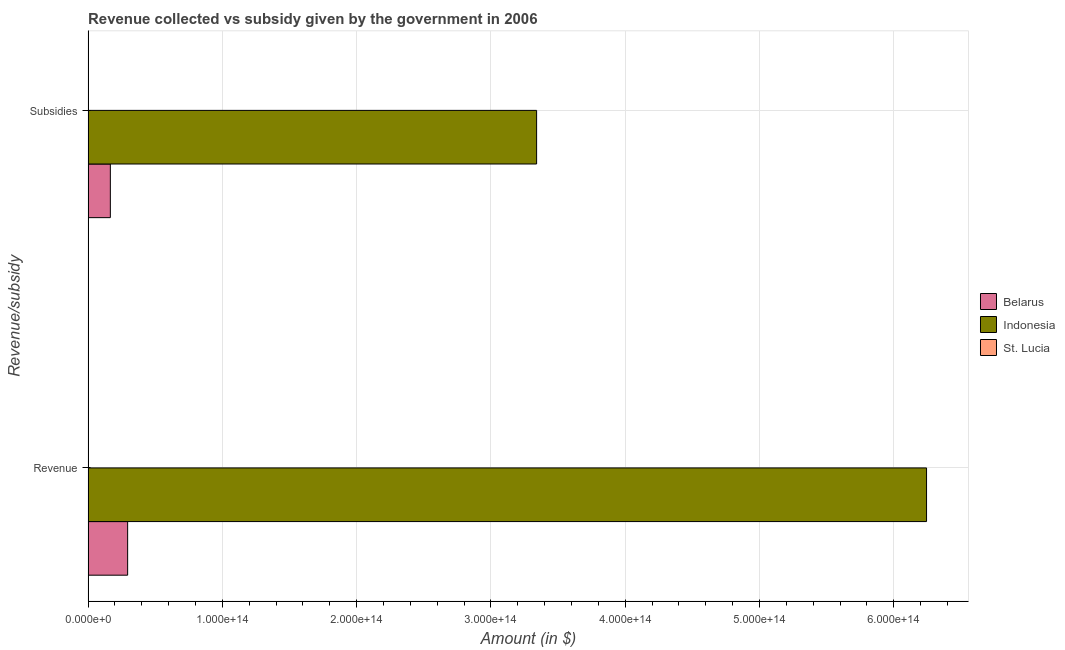How many different coloured bars are there?
Keep it short and to the point. 3. How many bars are there on the 1st tick from the top?
Make the answer very short. 3. What is the label of the 1st group of bars from the top?
Your answer should be very brief. Subsidies. What is the amount of subsidies given in Indonesia?
Provide a succinct answer. 3.34e+14. Across all countries, what is the maximum amount of subsidies given?
Provide a short and direct response. 3.34e+14. Across all countries, what is the minimum amount of subsidies given?
Your answer should be very brief. 4.63e+07. In which country was the amount of subsidies given maximum?
Provide a short and direct response. Indonesia. In which country was the amount of subsidies given minimum?
Offer a terse response. St. Lucia. What is the total amount of revenue collected in the graph?
Ensure brevity in your answer.  6.54e+14. What is the difference between the amount of revenue collected in St. Lucia and that in Belarus?
Provide a short and direct response. -2.94e+13. What is the difference between the amount of revenue collected in Indonesia and the amount of subsidies given in Belarus?
Keep it short and to the point. 6.08e+14. What is the average amount of revenue collected per country?
Keep it short and to the point. 2.18e+14. What is the difference between the amount of subsidies given and amount of revenue collected in Belarus?
Your answer should be compact. -1.29e+13. In how many countries, is the amount of revenue collected greater than 380000000000000 $?
Offer a very short reply. 1. What is the ratio of the amount of revenue collected in Belarus to that in St. Lucia?
Your response must be concise. 4.55e+04. Is the amount of subsidies given in St. Lucia less than that in Indonesia?
Provide a succinct answer. Yes. In how many countries, is the amount of revenue collected greater than the average amount of revenue collected taken over all countries?
Offer a very short reply. 1. What does the 3rd bar from the top in Subsidies represents?
Offer a terse response. Belarus. What does the 2nd bar from the bottom in Subsidies represents?
Make the answer very short. Indonesia. How many bars are there?
Make the answer very short. 6. How many countries are there in the graph?
Your answer should be very brief. 3. What is the difference between two consecutive major ticks on the X-axis?
Your response must be concise. 1.00e+14. Where does the legend appear in the graph?
Your response must be concise. Center right. How many legend labels are there?
Keep it short and to the point. 3. How are the legend labels stacked?
Give a very brief answer. Vertical. What is the title of the graph?
Make the answer very short. Revenue collected vs subsidy given by the government in 2006. What is the label or title of the X-axis?
Keep it short and to the point. Amount (in $). What is the label or title of the Y-axis?
Give a very brief answer. Revenue/subsidy. What is the Amount (in $) in Belarus in Revenue?
Ensure brevity in your answer.  2.94e+13. What is the Amount (in $) in Indonesia in Revenue?
Offer a terse response. 6.24e+14. What is the Amount (in $) in St. Lucia in Revenue?
Your answer should be very brief. 6.48e+08. What is the Amount (in $) in Belarus in Subsidies?
Your response must be concise. 1.66e+13. What is the Amount (in $) of Indonesia in Subsidies?
Keep it short and to the point. 3.34e+14. What is the Amount (in $) in St. Lucia in Subsidies?
Offer a terse response. 4.63e+07. Across all Revenue/subsidy, what is the maximum Amount (in $) of Belarus?
Make the answer very short. 2.94e+13. Across all Revenue/subsidy, what is the maximum Amount (in $) of Indonesia?
Your answer should be very brief. 6.24e+14. Across all Revenue/subsidy, what is the maximum Amount (in $) of St. Lucia?
Ensure brevity in your answer.  6.48e+08. Across all Revenue/subsidy, what is the minimum Amount (in $) of Belarus?
Provide a succinct answer. 1.66e+13. Across all Revenue/subsidy, what is the minimum Amount (in $) of Indonesia?
Give a very brief answer. 3.34e+14. Across all Revenue/subsidy, what is the minimum Amount (in $) in St. Lucia?
Provide a succinct answer. 4.63e+07. What is the total Amount (in $) in Belarus in the graph?
Your answer should be very brief. 4.60e+13. What is the total Amount (in $) in Indonesia in the graph?
Give a very brief answer. 9.58e+14. What is the total Amount (in $) in St. Lucia in the graph?
Offer a very short reply. 6.94e+08. What is the difference between the Amount (in $) of Belarus in Revenue and that in Subsidies?
Offer a terse response. 1.29e+13. What is the difference between the Amount (in $) of Indonesia in Revenue and that in Subsidies?
Give a very brief answer. 2.90e+14. What is the difference between the Amount (in $) of St. Lucia in Revenue and that in Subsidies?
Provide a short and direct response. 6.01e+08. What is the difference between the Amount (in $) of Belarus in Revenue and the Amount (in $) of Indonesia in Subsidies?
Keep it short and to the point. -3.05e+14. What is the difference between the Amount (in $) of Belarus in Revenue and the Amount (in $) of St. Lucia in Subsidies?
Give a very brief answer. 2.94e+13. What is the difference between the Amount (in $) in Indonesia in Revenue and the Amount (in $) in St. Lucia in Subsidies?
Provide a short and direct response. 6.24e+14. What is the average Amount (in $) in Belarus per Revenue/subsidy?
Your response must be concise. 2.30e+13. What is the average Amount (in $) in Indonesia per Revenue/subsidy?
Ensure brevity in your answer.  4.79e+14. What is the average Amount (in $) of St. Lucia per Revenue/subsidy?
Your answer should be very brief. 3.47e+08. What is the difference between the Amount (in $) of Belarus and Amount (in $) of Indonesia in Revenue?
Offer a terse response. -5.95e+14. What is the difference between the Amount (in $) in Belarus and Amount (in $) in St. Lucia in Revenue?
Offer a very short reply. 2.94e+13. What is the difference between the Amount (in $) of Indonesia and Amount (in $) of St. Lucia in Revenue?
Offer a terse response. 6.24e+14. What is the difference between the Amount (in $) in Belarus and Amount (in $) in Indonesia in Subsidies?
Ensure brevity in your answer.  -3.17e+14. What is the difference between the Amount (in $) in Belarus and Amount (in $) in St. Lucia in Subsidies?
Your answer should be compact. 1.66e+13. What is the difference between the Amount (in $) of Indonesia and Amount (in $) of St. Lucia in Subsidies?
Give a very brief answer. 3.34e+14. What is the ratio of the Amount (in $) of Belarus in Revenue to that in Subsidies?
Your response must be concise. 1.78. What is the ratio of the Amount (in $) in Indonesia in Revenue to that in Subsidies?
Your answer should be compact. 1.87. What is the ratio of the Amount (in $) of St. Lucia in Revenue to that in Subsidies?
Give a very brief answer. 13.99. What is the difference between the highest and the second highest Amount (in $) of Belarus?
Provide a short and direct response. 1.29e+13. What is the difference between the highest and the second highest Amount (in $) of Indonesia?
Provide a succinct answer. 2.90e+14. What is the difference between the highest and the second highest Amount (in $) in St. Lucia?
Make the answer very short. 6.01e+08. What is the difference between the highest and the lowest Amount (in $) in Belarus?
Your answer should be compact. 1.29e+13. What is the difference between the highest and the lowest Amount (in $) of Indonesia?
Your answer should be very brief. 2.90e+14. What is the difference between the highest and the lowest Amount (in $) of St. Lucia?
Give a very brief answer. 6.01e+08. 